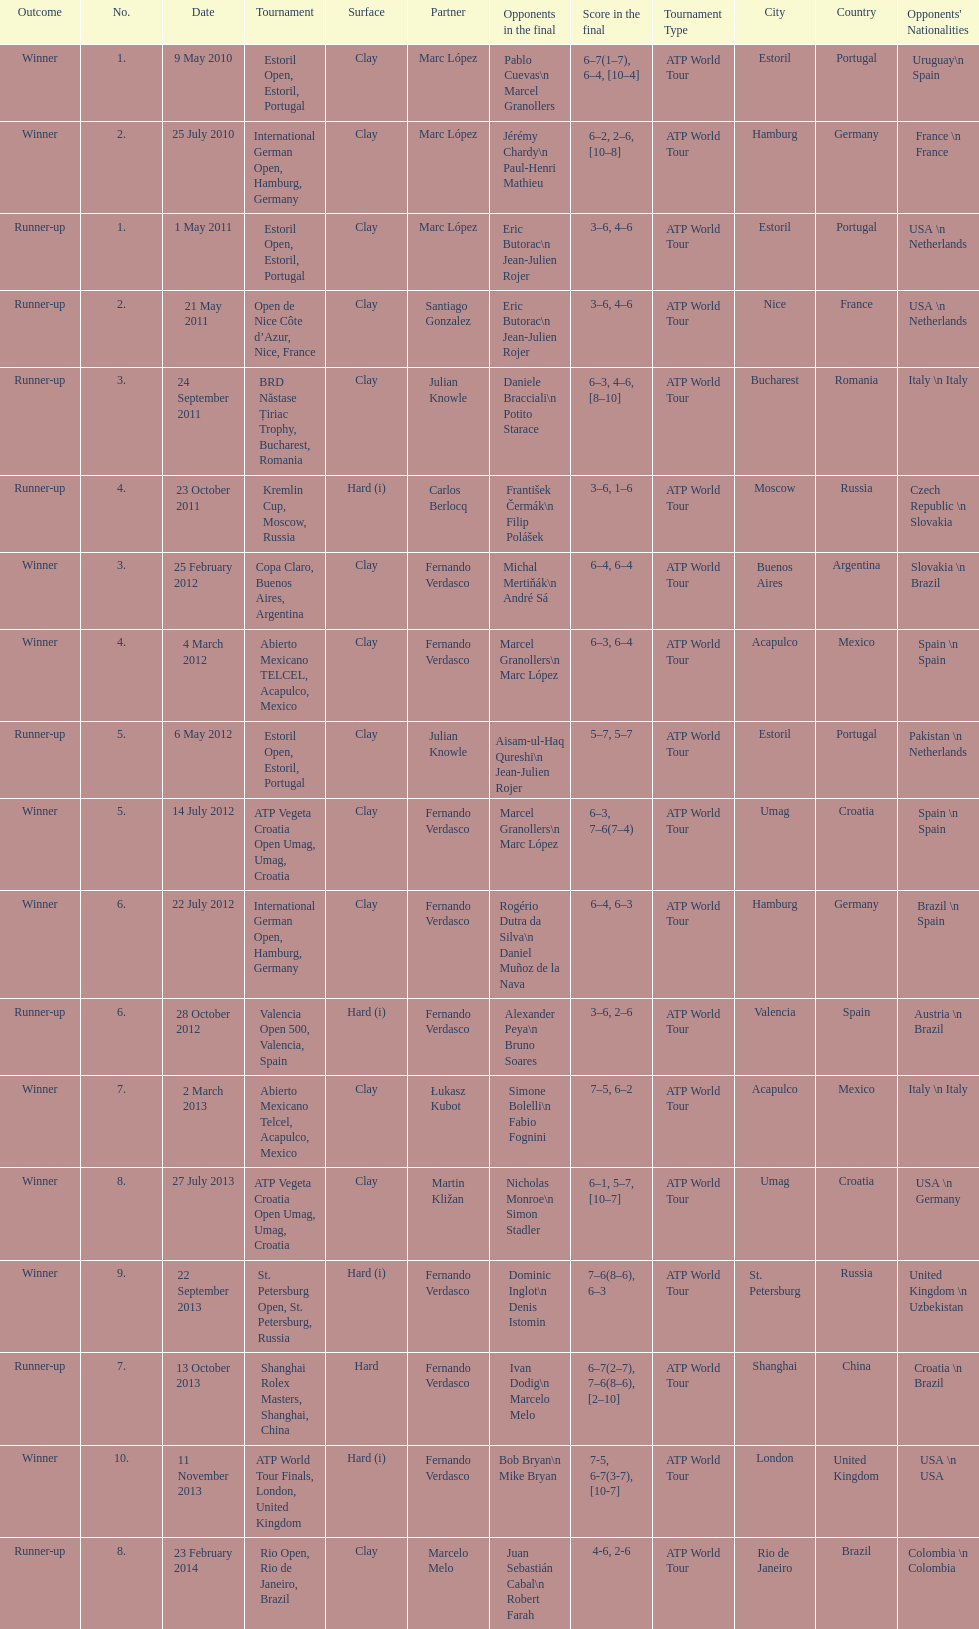How many partners from spain are listed? 2. 